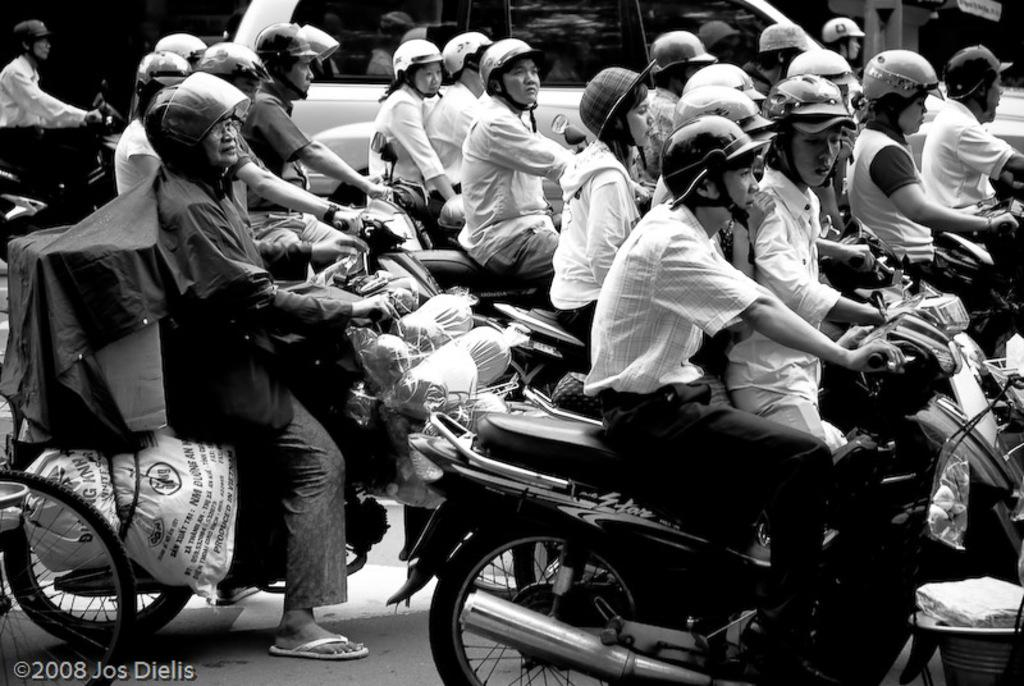Who or what can be seen in the image? There are people and vehicles on the road in the image. What is the color scheme of the image? The image is in black and white color. What is the profit of the governor in the image? There is no mention of profit or a governor in the image; it features people and vehicles on the road. 